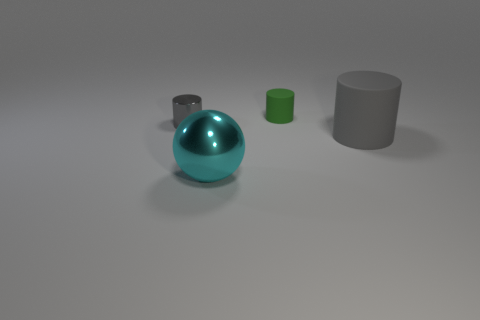Can you describe the shapes and their arrangement in this image? Certainly! The image shows three geometric shapes: a large, shiny cyan sphere; a reflective, medium-sized cylinder; and a small, matte-finish green cylinder. The sphere is centrally placed and becomes the focal point due to its size and reflective surface. The medium cylinder is situated to the left of the sphere, and the small cylinder is positioned behind the sphere. This arrangement creates a descending order of size and draws attention to the textural differences between the objects. 